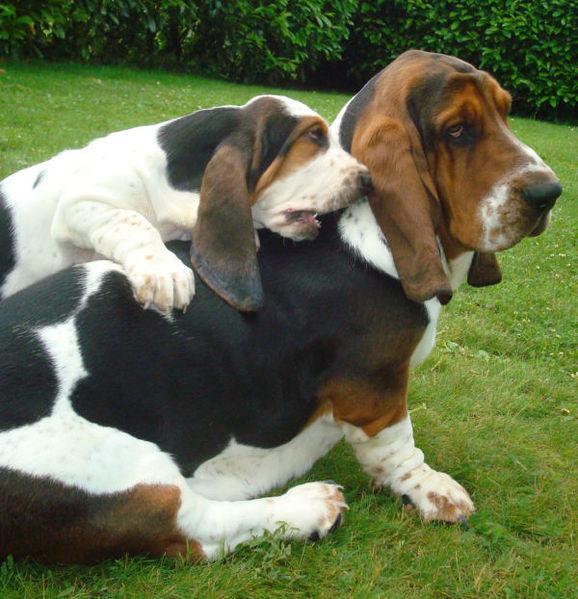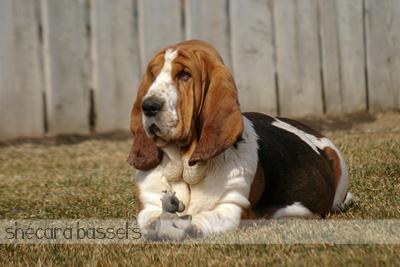The first image is the image on the left, the second image is the image on the right. Assess this claim about the two images: "The right image shows one basset hound reclining on the ground, and the left image shows two hounds interacting.". Correct or not? Answer yes or no. Yes. The first image is the image on the left, the second image is the image on the right. Assess this claim about the two images: "There is exactly two dogs in the left image.". Correct or not? Answer yes or no. Yes. 